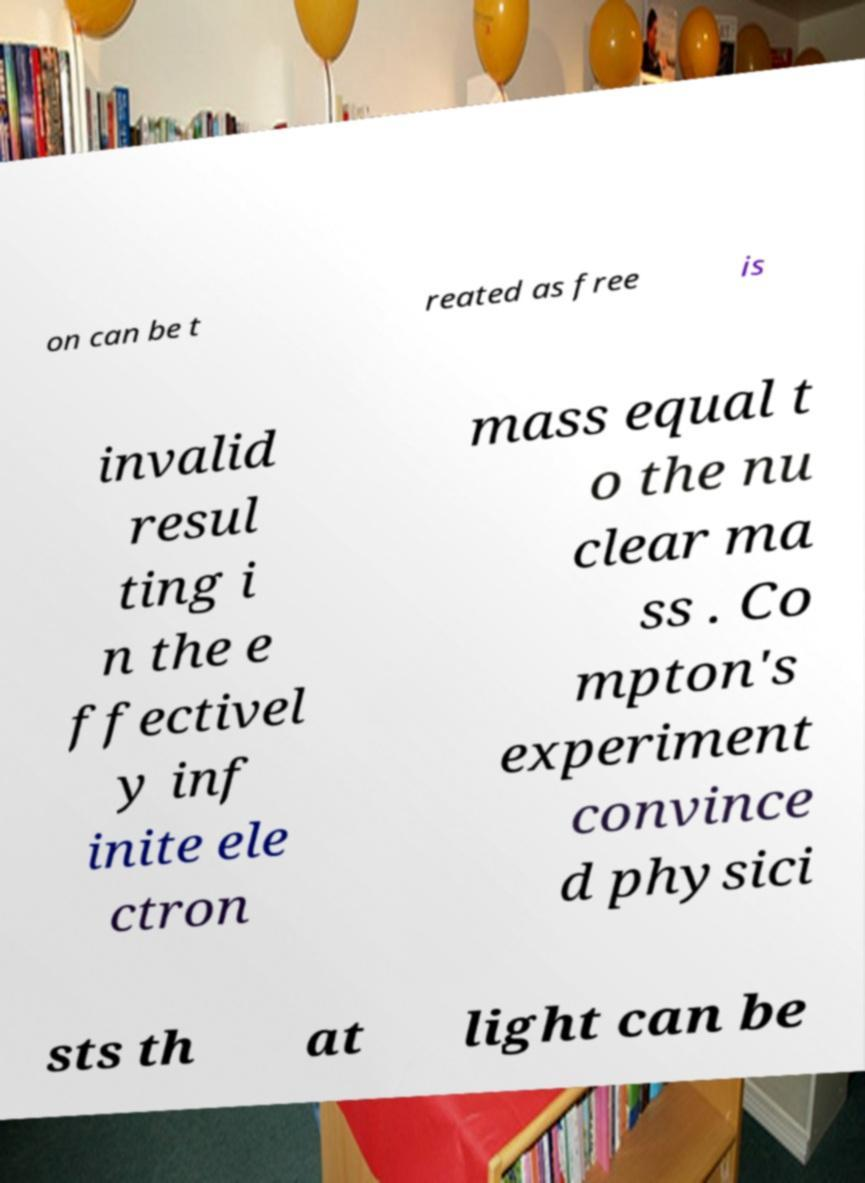I need the written content from this picture converted into text. Can you do that? on can be t reated as free is invalid resul ting i n the e ffectivel y inf inite ele ctron mass equal t o the nu clear ma ss . Co mpton's experiment convince d physici sts th at light can be 